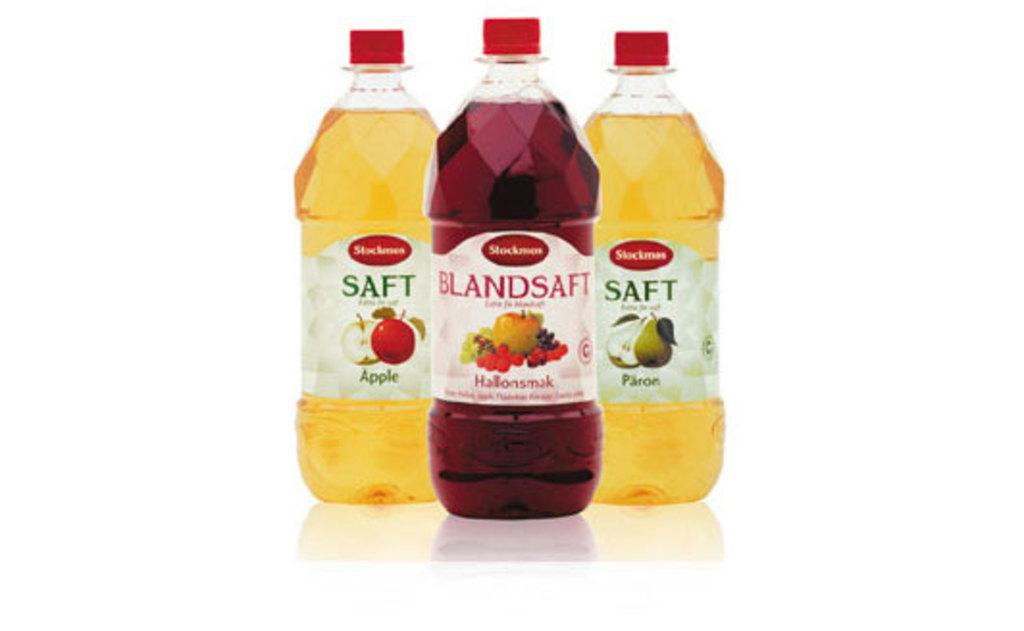How many bottles are visible in the image? There are three bottles in the image. What type of wool is being spun by the grandmother in the image? There is no wool or grandmother present in the image; it only features three bottles. 